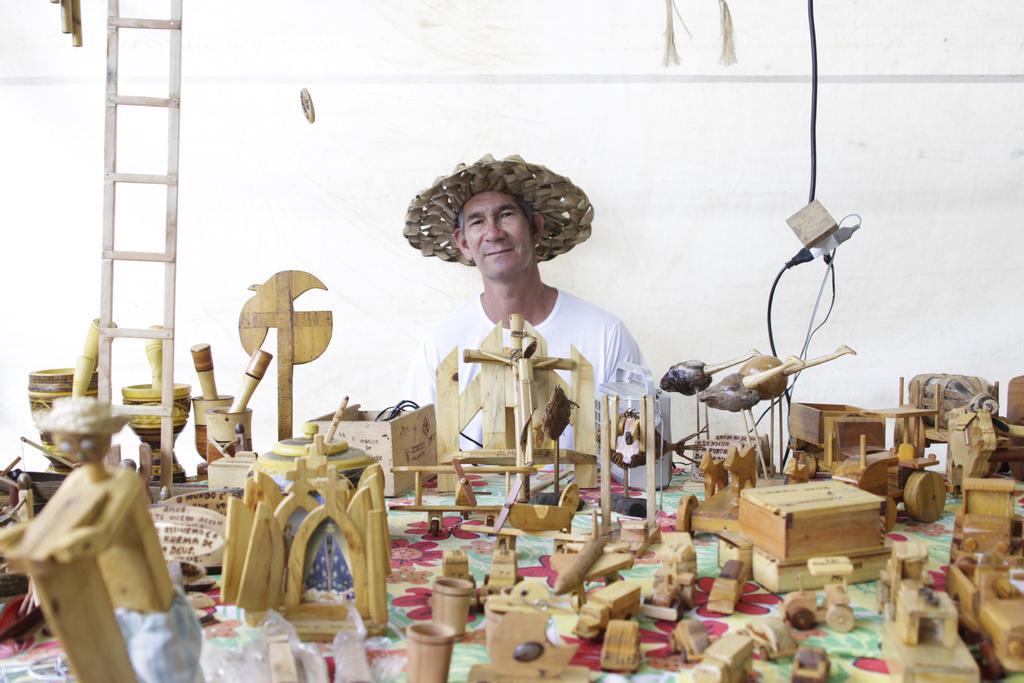Can you describe this image briefly? In this image there is a man, he is wearing a hat, there is a table towards the bottom of the image, there is a cloth on the table, there are objects on the cloth, there is a ladder towards the top of the image, there is a ladder towards the top of the image, there are wires, there are objects towards the top of the image, at the background of the image there is a wall, the background of the image is white in color. 